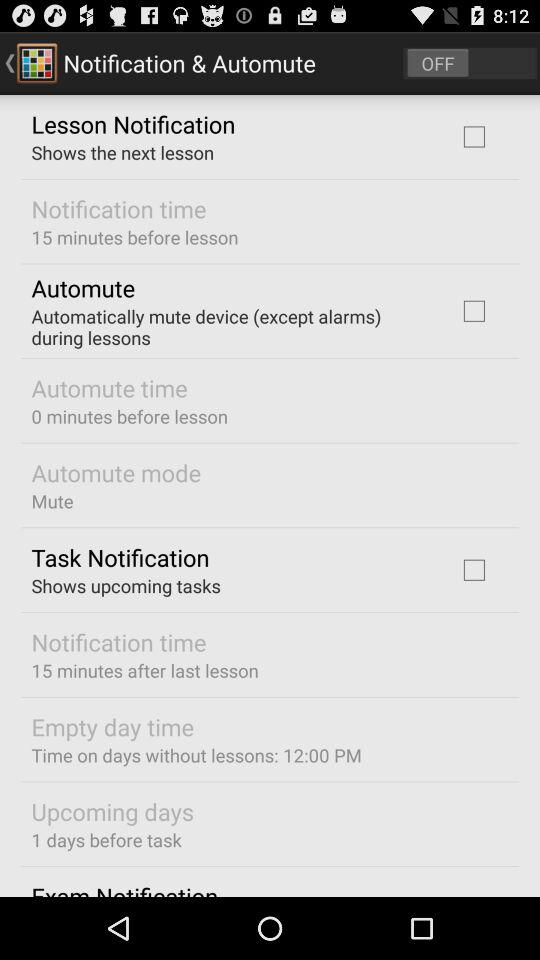What is the "Time on days without lessons"? "Time on days without lessons" is 12:00 PM. 